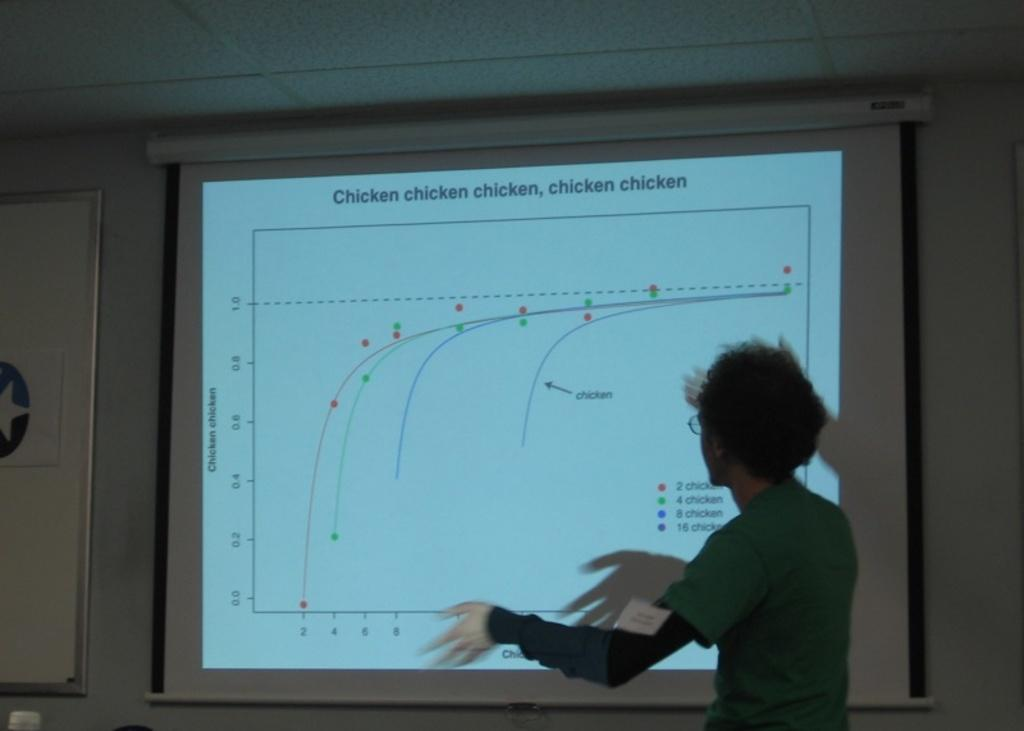<image>
Offer a succinct explanation of the picture presented. A Person stands in front of a screen and gives a presentation titled "Chicken, chicken, chicken, chicken". 